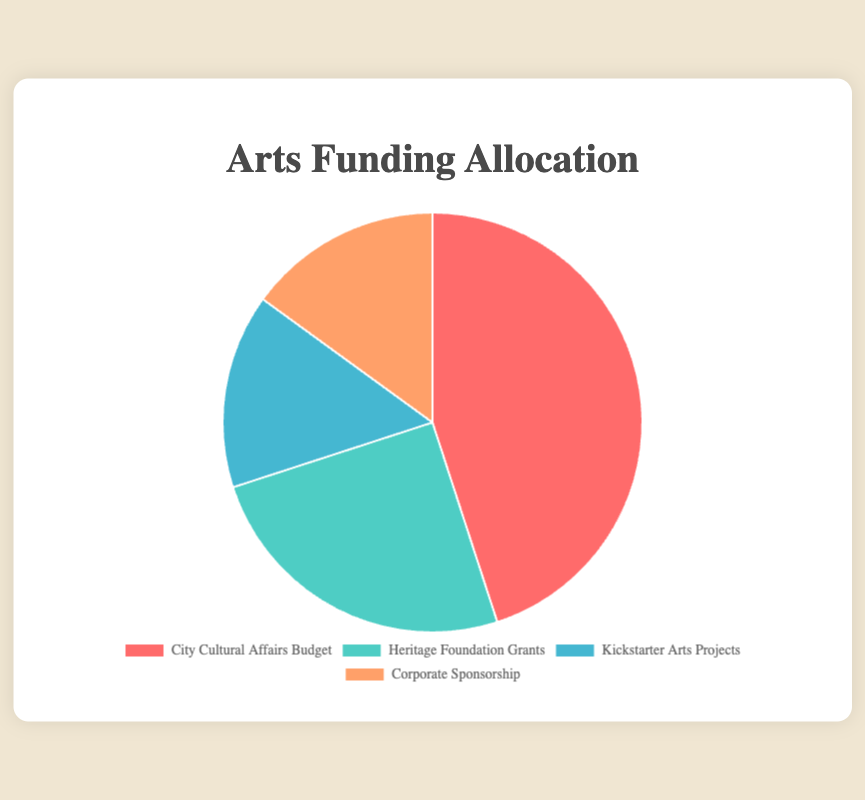What entity has the largest percentage in the Arts Funding Allocation? The chart shows that "City Cultural Affairs Budget" covers 45%, which is the largest slice of the pie.
Answer: City Cultural Affairs Budget Which two entities each occupy exactly 15% of the Arts Funding Allocation? Observing the chart, both "Kickstarter Arts Projects" and "Corporate Sponsorship" each have a 15% share.
Answer: Kickstarter Arts Projects and Corporate Sponsorship What is the percentage difference between Public and Private funding? The "City Cultural Affairs Budget" has 45% and the "Heritage Foundation Grants" have 25%. Subtracting these gives 45% - 25% = 20%.
Answer: 20% What is the combined percentage for Crowdfunding and Sponsorship funding? Adding the percentages for "Kickstarter Arts Projects" (15%) and "Corporate Sponsorship" (15%) gives 15% + 15% = 30%.
Answer: 30% What color represents the entity with the smallest share of Arts Funding Allocation? "Kickstarter Arts Projects" and "Corporate Sponsorship" are both 15%, and the colors for these are light blue and orange, respectively.
Answer: Light blue or Orange Which sector receives the second highest level of funding? The chart shows "Heritage Foundation Grants" at 25%, which is the second highest percentage after the "City Cultural Affairs Budget".
Answer: Heritage Foundation Grants How does the sum of Private and Public funding compare to the sum of Crowdfunding and Sponsorship? Public funding is 45% and Private funding is 25%, so 45% + 25% = 70%. Crowdfunding is 15% and Sponsorship is also 15%, giving a sum of 15% + 15% = 30%. Thus, 70% of Public + Private is greater than 30% of Crowdfunding + Sponsorship.
Answer: 70% vs 30% If the City Cultural Affairs Budget increased by 10%, what would its new percentage be? The current percentage is 45%. Adding 10% to this gives 45% + 10% = 55%.
Answer: 55% What two colors represent the highest and lowest percentages in the Arts Funding Allocation? The highest percentage (45%) "City Cultural Affairs Budget" is red, and the lowest percentages (15%) "Kickstarter Arts Projects" and "Corporate Sponsorship" are light blue and orange.
Answer: Red and light blue or orange What is the average percentage of the four funding types? Summing all percentages (45 + 25 + 15 + 15) = 100 and then dividing by 4 gives 100 / 4 = 25%.
Answer: 25% 